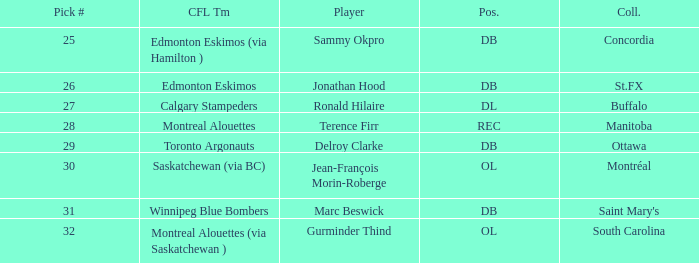Which Pick # has a College of concordia? 25.0. Help me parse the entirety of this table. {'header': ['Pick #', 'CFL Tm', 'Player', 'Pos.', 'Coll.'], 'rows': [['25', 'Edmonton Eskimos (via Hamilton )', 'Sammy Okpro', 'DB', 'Concordia'], ['26', 'Edmonton Eskimos', 'Jonathan Hood', 'DB', 'St.FX'], ['27', 'Calgary Stampeders', 'Ronald Hilaire', 'DL', 'Buffalo'], ['28', 'Montreal Alouettes', 'Terence Firr', 'REC', 'Manitoba'], ['29', 'Toronto Argonauts', 'Delroy Clarke', 'DB', 'Ottawa'], ['30', 'Saskatchewan (via BC)', 'Jean-François Morin-Roberge', 'OL', 'Montréal'], ['31', 'Winnipeg Blue Bombers', 'Marc Beswick', 'DB', "Saint Mary's"], ['32', 'Montreal Alouettes (via Saskatchewan )', 'Gurminder Thind', 'OL', 'South Carolina']]} 